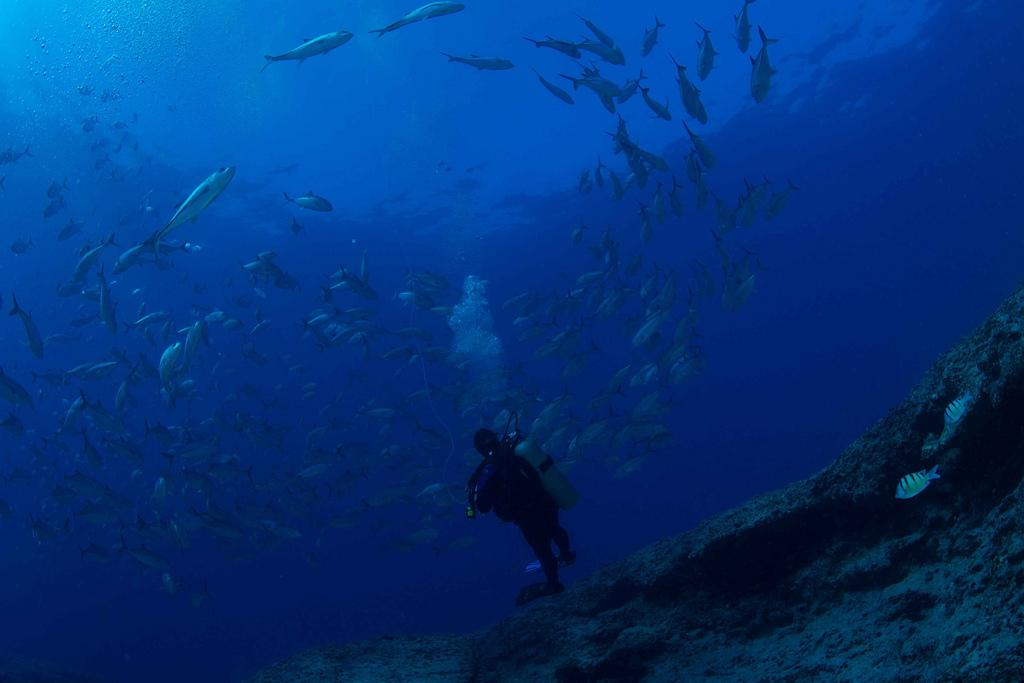What is the man in the image doing? The man is swimming in the water. What is attached to the man's back? The man is carrying an oxygen cylinder on his back. What else can be seen in the water besides the man? There are many fishes in the water. How many mice are swimming alongside the man in the image? There are no mice present in the image; it only features the man swimming with an oxygen cylinder and fishes in the water. 